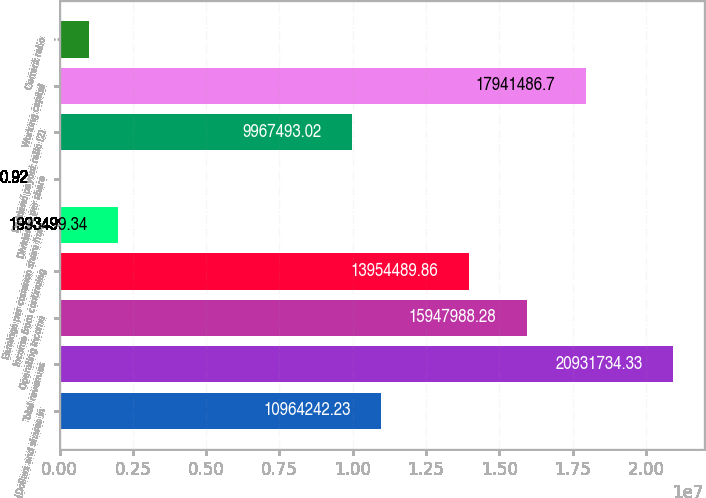<chart> <loc_0><loc_0><loc_500><loc_500><bar_chart><fcel>(Dollars and shares in<fcel>Total revenues<fcel>Operating income<fcel>Income from continuing<fcel>Earnings per common share from<fcel>Dividends per share<fcel>Dividend payout ratio (2)<fcel>Working capital<fcel>Current ratio<nl><fcel>1.09642e+07<fcel>2.09317e+07<fcel>1.5948e+07<fcel>1.39545e+07<fcel>1.9935e+06<fcel>0.92<fcel>9.96749e+06<fcel>1.79415e+07<fcel>996750<nl></chart> 